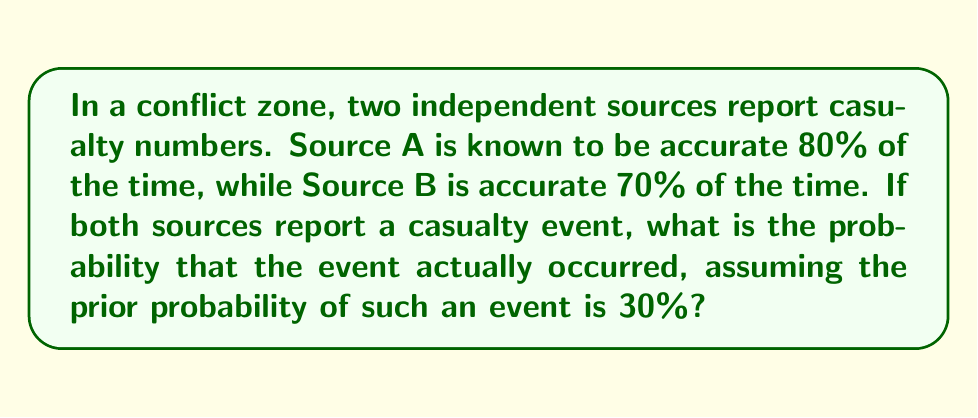Help me with this question. Let's approach this problem using Bayes' theorem and probability theory:

1) Define events:
   E: The casualty event actually occurred
   A: Source A reports the event
   B: Source B reports the event

2) Given information:
   P(A|E) = 0.80 (Source A's accuracy)
   P(B|E) = 0.70 (Source B's accuracy)
   P(E) = 0.30 (Prior probability of the event)

3) We need to find P(E|A∩B) using Bayes' theorem:

   $$P(E|A∩B) = \frac{P(A∩B|E) \cdot P(E)}{P(A∩B)}$$

4) Calculate P(A∩B|E):
   Since the sources are independent, P(A∩B|E) = P(A|E) · P(B|E)
   $$P(A∩B|E) = 0.80 \cdot 0.70 = 0.56$$

5) Calculate P(A∩B):
   $$P(A∩B) = P(A∩B|E) \cdot P(E) + P(A∩B|not E) \cdot P(not E)$$
   
   We know P(A∩B|E) and P(E). We need to calculate:
   P(not E) = 1 - P(E) = 0.70
   P(A∩B|not E) = P(A|not E) · P(B|not E) = 0.20 · 0.30 = 0.06
   
   $$P(A∩B) = 0.56 \cdot 0.30 + 0.06 \cdot 0.70 = 0.168 + 0.042 = 0.21$$

6) Now we can apply Bayes' theorem:

   $$P(E|A∩B) = \frac{0.56 \cdot 0.30}{0.21} \approx 0.80$$

Therefore, the probability that the casualty event actually occurred, given that both sources reported it, is approximately 0.80 or 80%.
Answer: 0.80 or 80% 